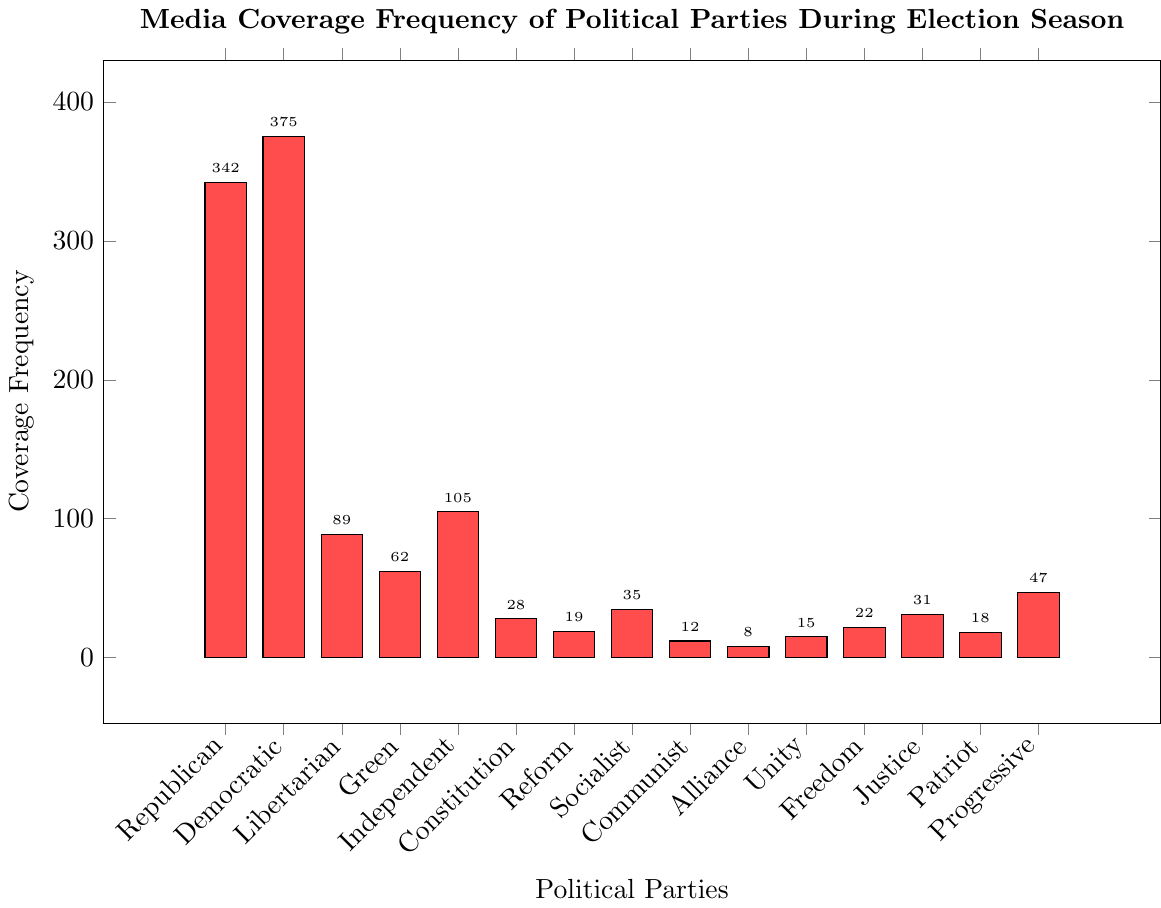Which political party received the highest media coverage frequency? The bar with the highest height represents the Democratic Party. By checking the y-axis, we see that its frequency is 375, which is the highest among all parties.
Answer: Democratic Which party had the lowest media coverage frequency? The bar representing the Alliance Party is the shortest on the chart, indicating it had the lowest coverage frequency of 8.
Answer: Alliance What is the sum of the media coverage frequencies for the parties with the second and third highest coverage? The second highest frequency is the Republican Party with 342 and the third highest is the Independent Party with 105. Adding these together gives 342 + 105 = 447.
Answer: 447 How does the coverage frequency of the Progressive Party compare to the Libertarian Party? The height of the bars representing these parties shows the Libertarian Party with a coverage frequency of 89, while the Progressive Party has 47. Comparing these values, we see that the Libertarian Party had a higher coverage frequency.
Answer: Libertarian received higher coverage than Progressive What is the difference in media coverage frequency between the Socialist and the Reform parties? The Socialist Party has a coverage of 35, while the Reform Party has 19. The difference is 35 - 19 = 16.
Answer: 16 How many parties received a media coverage frequency of less than 50? The parties with coverage frequencies less than 50 can be identified by the shorter bars: Green (62), Constitution (28), Reform (19), Socialist (35), Communist (12), Alliance (8), Unity (15), Freedom (22), Justice (31), Patriot (18), and Progressive (47). There are 9 parties in total.
Answer: 9 What percentage of the total media coverage did the Democratic party receive? First, sum all the frequencies: 375 + 342 + 89 + 62 + 105 + 28 + 19 + 35 + 12 + 8 + 15 + 22 + 31 + 18 + 47 = 1208. The Democratic Party's share is (375 / 1208) * 100 ≈ 31.05%.
Answer: 31.05% Which party received more media coverage, the Justice Party or the Patriot Party, and by how much? The Justice Party has a frequency of 31 and the Patriot Party has 18. The difference is 31 - 18 = 13.
Answer: Justice Party by 13 